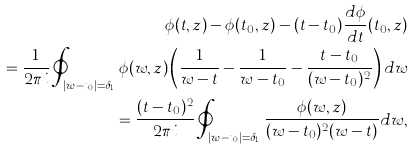Convert formula to latex. <formula><loc_0><loc_0><loc_500><loc_500>\phi ( t , z ) - \phi ( t _ { 0 } , z ) - ( t - t _ { 0 } ) \frac { d \phi } { d t } ( t _ { 0 } , z ) \\ = \frac { 1 } { 2 \pi i } \oint _ { | w - t _ { 0 } | = \delta _ { 1 } } \phi ( w , z ) \left ( \frac { 1 } { w - t } - \frac { 1 } { w - t _ { 0 } } - \frac { t - t _ { 0 } } { ( w - t _ { 0 } ) ^ { 2 } } \right ) d w \\ = \frac { ( t - t _ { 0 } ) ^ { 2 } } { 2 \pi i } \oint _ { | w - t _ { 0 } | = \delta _ { 1 } } \frac { \phi ( w , z ) } { ( w - t _ { 0 } ) ^ { 2 } ( w - t ) } d w ,</formula> 